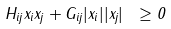<formula> <loc_0><loc_0><loc_500><loc_500>H _ { i j } x _ { i } x _ { j } + G _ { i j } | x _ { i } | | x _ { j } | \ \geq 0</formula> 